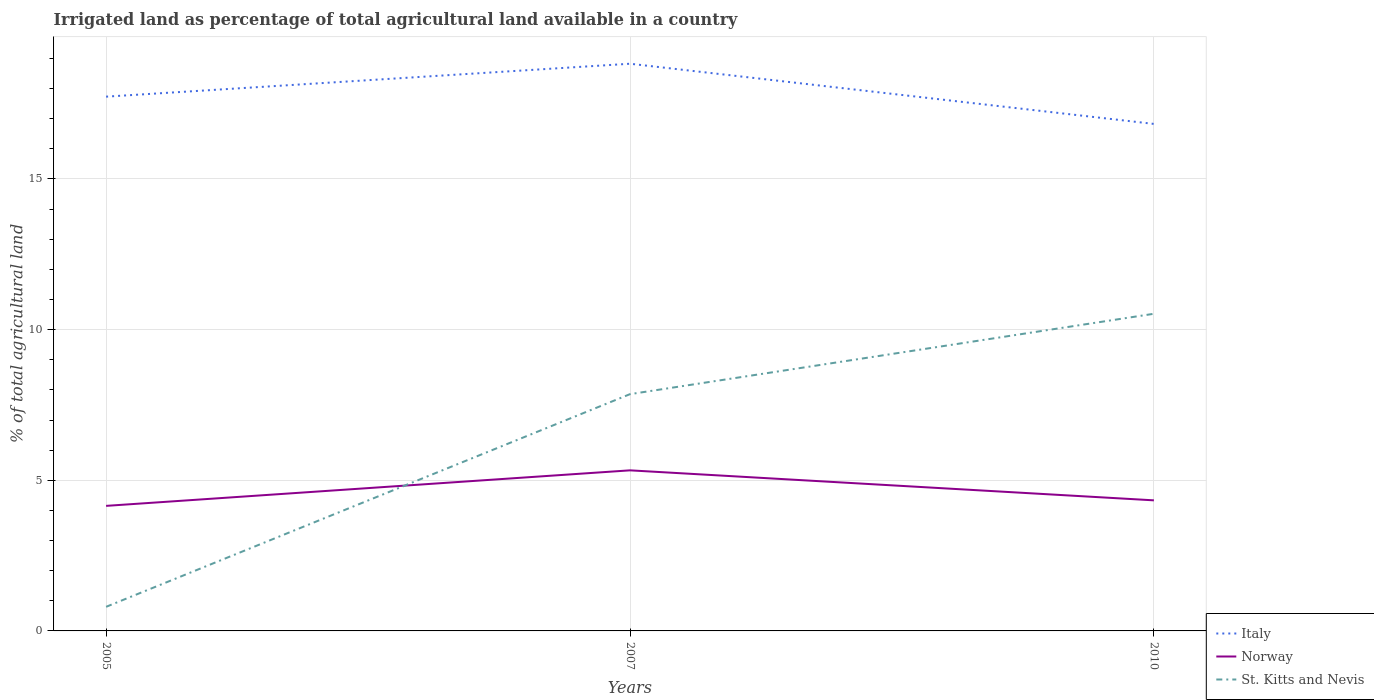How many different coloured lines are there?
Make the answer very short. 3. In which year was the percentage of irrigated land in Italy maximum?
Offer a terse response. 2010. What is the total percentage of irrigated land in Norway in the graph?
Provide a short and direct response. 1. What is the difference between the highest and the second highest percentage of irrigated land in Italy?
Your answer should be compact. 2. How many years are there in the graph?
Your answer should be compact. 3. Does the graph contain grids?
Keep it short and to the point. Yes. How many legend labels are there?
Keep it short and to the point. 3. How are the legend labels stacked?
Provide a short and direct response. Vertical. What is the title of the graph?
Make the answer very short. Irrigated land as percentage of total agricultural land available in a country. What is the label or title of the X-axis?
Give a very brief answer. Years. What is the label or title of the Y-axis?
Keep it short and to the point. % of total agricultural land. What is the % of total agricultural land in Italy in 2005?
Ensure brevity in your answer.  17.73. What is the % of total agricultural land of Norway in 2005?
Your answer should be compact. 4.15. What is the % of total agricultural land of St. Kitts and Nevis in 2005?
Provide a short and direct response. 0.8. What is the % of total agricultural land in Italy in 2007?
Your response must be concise. 18.83. What is the % of total agricultural land of Norway in 2007?
Offer a terse response. 5.33. What is the % of total agricultural land of St. Kitts and Nevis in 2007?
Offer a terse response. 7.86. What is the % of total agricultural land of Italy in 2010?
Your answer should be compact. 16.83. What is the % of total agricultural land in Norway in 2010?
Offer a very short reply. 4.33. What is the % of total agricultural land of St. Kitts and Nevis in 2010?
Offer a terse response. 10.53. Across all years, what is the maximum % of total agricultural land in Italy?
Give a very brief answer. 18.83. Across all years, what is the maximum % of total agricultural land in Norway?
Your answer should be very brief. 5.33. Across all years, what is the maximum % of total agricultural land of St. Kitts and Nevis?
Your answer should be very brief. 10.53. Across all years, what is the minimum % of total agricultural land in Italy?
Give a very brief answer. 16.83. Across all years, what is the minimum % of total agricultural land of Norway?
Offer a terse response. 4.15. What is the total % of total agricultural land in Italy in the graph?
Make the answer very short. 53.38. What is the total % of total agricultural land of Norway in the graph?
Provide a short and direct response. 13.81. What is the total % of total agricultural land in St. Kitts and Nevis in the graph?
Offer a terse response. 19.18. What is the difference between the % of total agricultural land in Italy in 2005 and that in 2007?
Offer a very short reply. -1.09. What is the difference between the % of total agricultural land in Norway in 2005 and that in 2007?
Keep it short and to the point. -1.18. What is the difference between the % of total agricultural land in St. Kitts and Nevis in 2005 and that in 2007?
Provide a short and direct response. -7.06. What is the difference between the % of total agricultural land of Italy in 2005 and that in 2010?
Give a very brief answer. 0.9. What is the difference between the % of total agricultural land in Norway in 2005 and that in 2010?
Your answer should be very brief. -0.18. What is the difference between the % of total agricultural land in St. Kitts and Nevis in 2005 and that in 2010?
Your response must be concise. -9.73. What is the difference between the % of total agricultural land of Italy in 2007 and that in 2010?
Provide a succinct answer. 2. What is the difference between the % of total agricultural land in St. Kitts and Nevis in 2007 and that in 2010?
Keep it short and to the point. -2.67. What is the difference between the % of total agricultural land in Italy in 2005 and the % of total agricultural land in Norway in 2007?
Offer a very short reply. 12.4. What is the difference between the % of total agricultural land of Italy in 2005 and the % of total agricultural land of St. Kitts and Nevis in 2007?
Ensure brevity in your answer.  9.87. What is the difference between the % of total agricultural land in Norway in 2005 and the % of total agricultural land in St. Kitts and Nevis in 2007?
Offer a very short reply. -3.71. What is the difference between the % of total agricultural land of Italy in 2005 and the % of total agricultural land of Norway in 2010?
Provide a short and direct response. 13.4. What is the difference between the % of total agricultural land in Italy in 2005 and the % of total agricultural land in St. Kitts and Nevis in 2010?
Give a very brief answer. 7.21. What is the difference between the % of total agricultural land of Norway in 2005 and the % of total agricultural land of St. Kitts and Nevis in 2010?
Give a very brief answer. -6.38. What is the difference between the % of total agricultural land in Italy in 2007 and the % of total agricultural land in Norway in 2010?
Give a very brief answer. 14.49. What is the difference between the % of total agricultural land of Italy in 2007 and the % of total agricultural land of St. Kitts and Nevis in 2010?
Your answer should be compact. 8.3. What is the difference between the % of total agricultural land in Norway in 2007 and the % of total agricultural land in St. Kitts and Nevis in 2010?
Offer a very short reply. -5.2. What is the average % of total agricultural land of Italy per year?
Give a very brief answer. 17.79. What is the average % of total agricultural land in Norway per year?
Provide a short and direct response. 4.6. What is the average % of total agricultural land in St. Kitts and Nevis per year?
Give a very brief answer. 6.39. In the year 2005, what is the difference between the % of total agricultural land of Italy and % of total agricultural land of Norway?
Give a very brief answer. 13.58. In the year 2005, what is the difference between the % of total agricultural land of Italy and % of total agricultural land of St. Kitts and Nevis?
Keep it short and to the point. 16.93. In the year 2005, what is the difference between the % of total agricultural land in Norway and % of total agricultural land in St. Kitts and Nevis?
Offer a terse response. 3.35. In the year 2007, what is the difference between the % of total agricultural land of Italy and % of total agricultural land of Norway?
Ensure brevity in your answer.  13.5. In the year 2007, what is the difference between the % of total agricultural land of Italy and % of total agricultural land of St. Kitts and Nevis?
Provide a succinct answer. 10.97. In the year 2007, what is the difference between the % of total agricultural land of Norway and % of total agricultural land of St. Kitts and Nevis?
Make the answer very short. -2.53. In the year 2010, what is the difference between the % of total agricultural land of Italy and % of total agricultural land of Norway?
Give a very brief answer. 12.49. In the year 2010, what is the difference between the % of total agricultural land in Italy and % of total agricultural land in St. Kitts and Nevis?
Make the answer very short. 6.3. In the year 2010, what is the difference between the % of total agricultural land in Norway and % of total agricultural land in St. Kitts and Nevis?
Your answer should be very brief. -6.19. What is the ratio of the % of total agricultural land in Italy in 2005 to that in 2007?
Ensure brevity in your answer.  0.94. What is the ratio of the % of total agricultural land in Norway in 2005 to that in 2007?
Your answer should be very brief. 0.78. What is the ratio of the % of total agricultural land of St. Kitts and Nevis in 2005 to that in 2007?
Offer a very short reply. 0.1. What is the ratio of the % of total agricultural land of Italy in 2005 to that in 2010?
Give a very brief answer. 1.05. What is the ratio of the % of total agricultural land in Norway in 2005 to that in 2010?
Ensure brevity in your answer.  0.96. What is the ratio of the % of total agricultural land of St. Kitts and Nevis in 2005 to that in 2010?
Your response must be concise. 0.08. What is the ratio of the % of total agricultural land of Italy in 2007 to that in 2010?
Ensure brevity in your answer.  1.12. What is the ratio of the % of total agricultural land of Norway in 2007 to that in 2010?
Offer a terse response. 1.23. What is the ratio of the % of total agricultural land in St. Kitts and Nevis in 2007 to that in 2010?
Your response must be concise. 0.75. What is the difference between the highest and the second highest % of total agricultural land in Italy?
Offer a very short reply. 1.09. What is the difference between the highest and the second highest % of total agricultural land of St. Kitts and Nevis?
Give a very brief answer. 2.67. What is the difference between the highest and the lowest % of total agricultural land in Italy?
Your response must be concise. 2. What is the difference between the highest and the lowest % of total agricultural land in Norway?
Ensure brevity in your answer.  1.18. What is the difference between the highest and the lowest % of total agricultural land in St. Kitts and Nevis?
Offer a very short reply. 9.73. 